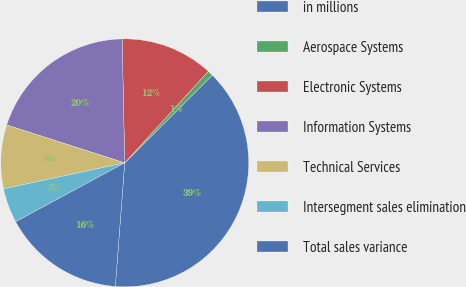Convert chart to OTSL. <chart><loc_0><loc_0><loc_500><loc_500><pie_chart><fcel>in millions<fcel>Aerospace Systems<fcel>Electronic Systems<fcel>Information Systems<fcel>Technical Services<fcel>Intersegment sales elimination<fcel>Total sales variance<nl><fcel>38.72%<fcel>0.71%<fcel>12.11%<fcel>19.72%<fcel>8.31%<fcel>4.51%<fcel>15.91%<nl></chart> 